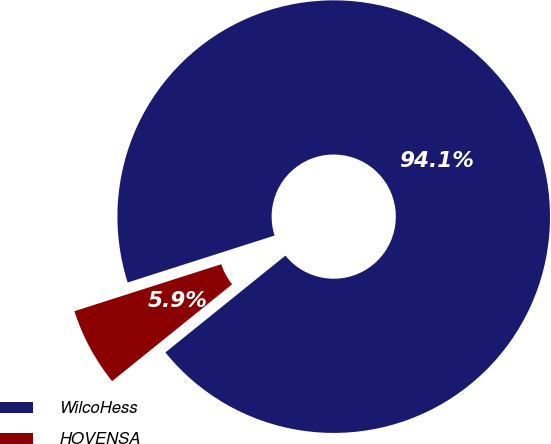Convert chart to OTSL. <chart><loc_0><loc_0><loc_500><loc_500><pie_chart><fcel>WilcoHess<fcel>HOVENSA<nl><fcel>94.12%<fcel>5.88%<nl></chart> 